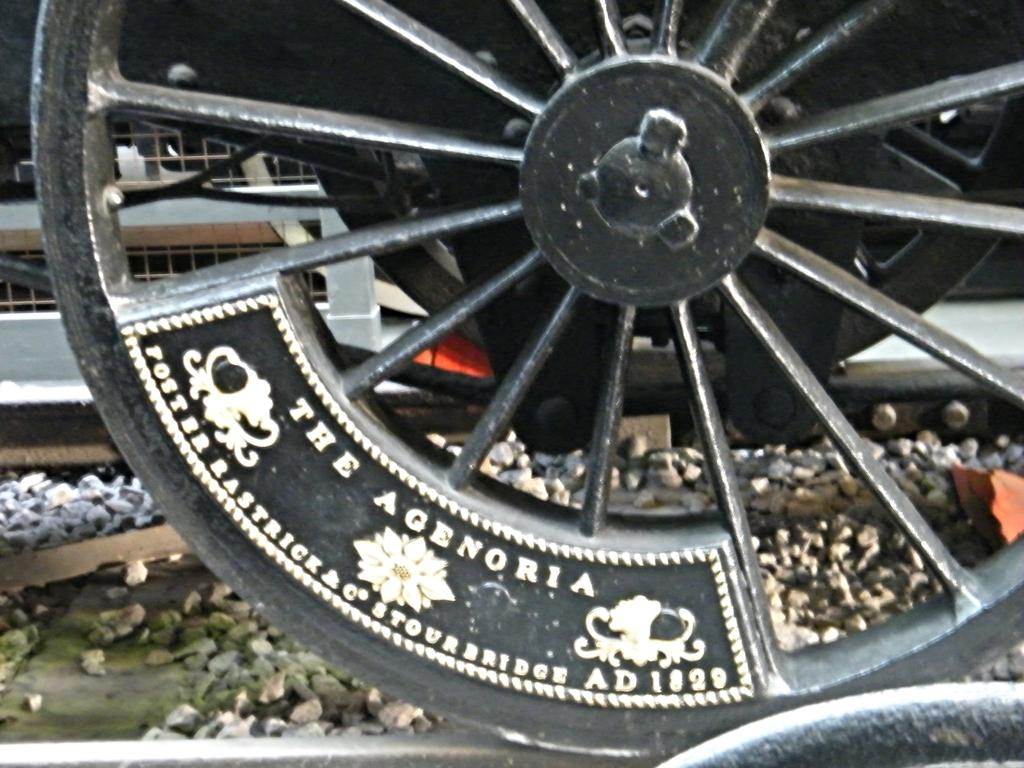<image>
Give a short and clear explanation of the subsequent image. A black spoked wheel says "The Agenoria" on it. 